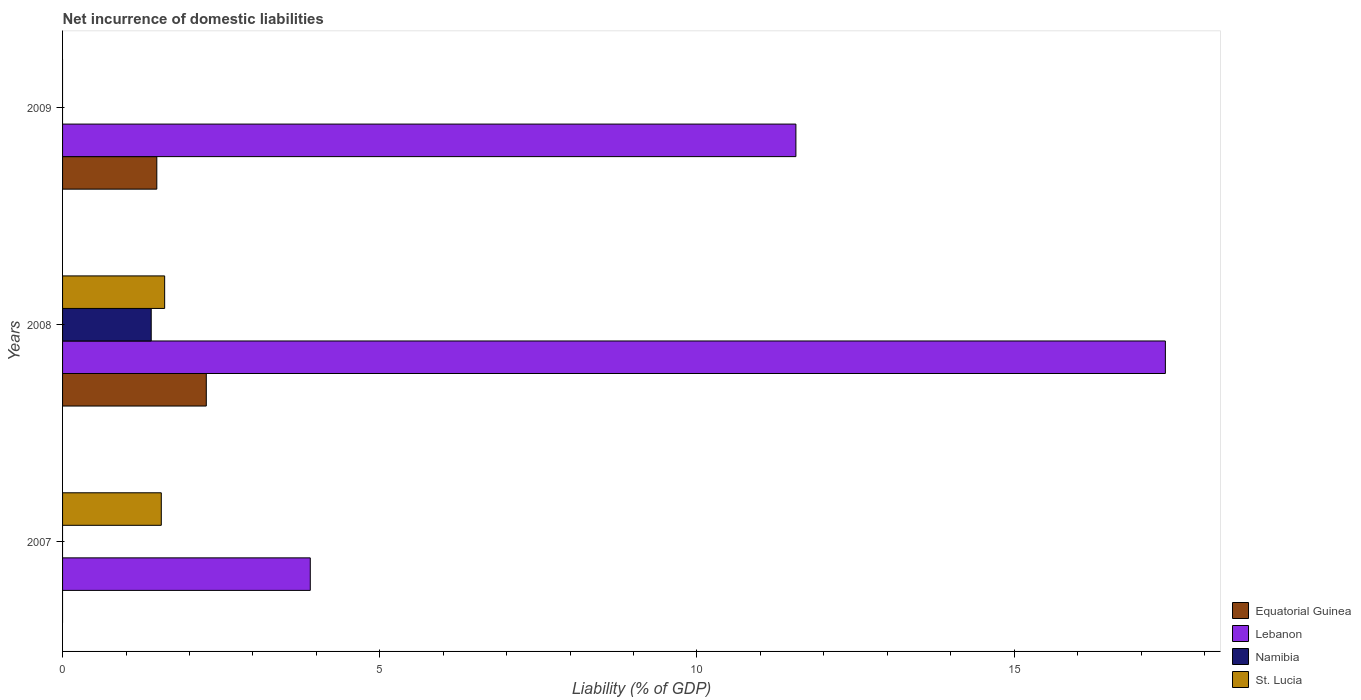How many different coloured bars are there?
Provide a short and direct response. 4. How many groups of bars are there?
Provide a succinct answer. 3. Are the number of bars per tick equal to the number of legend labels?
Your answer should be compact. No. In how many cases, is the number of bars for a given year not equal to the number of legend labels?
Offer a terse response. 2. Across all years, what is the maximum net incurrence of domestic liabilities in Namibia?
Give a very brief answer. 1.4. Across all years, what is the minimum net incurrence of domestic liabilities in St. Lucia?
Make the answer very short. 0. What is the total net incurrence of domestic liabilities in Equatorial Guinea in the graph?
Offer a very short reply. 3.75. What is the difference between the net incurrence of domestic liabilities in Lebanon in 2007 and that in 2008?
Make the answer very short. -13.48. What is the difference between the net incurrence of domestic liabilities in Namibia in 2009 and the net incurrence of domestic liabilities in St. Lucia in 2007?
Give a very brief answer. -1.56. What is the average net incurrence of domestic liabilities in Lebanon per year?
Offer a terse response. 10.95. In the year 2007, what is the difference between the net incurrence of domestic liabilities in St. Lucia and net incurrence of domestic liabilities in Lebanon?
Offer a terse response. -2.35. What is the ratio of the net incurrence of domestic liabilities in Lebanon in 2008 to that in 2009?
Ensure brevity in your answer.  1.5. What is the difference between the highest and the second highest net incurrence of domestic liabilities in Lebanon?
Your response must be concise. 5.82. What is the difference between the highest and the lowest net incurrence of domestic liabilities in Equatorial Guinea?
Provide a short and direct response. 2.27. Is the sum of the net incurrence of domestic liabilities in Equatorial Guinea in 2008 and 2009 greater than the maximum net incurrence of domestic liabilities in Namibia across all years?
Ensure brevity in your answer.  Yes. Is it the case that in every year, the sum of the net incurrence of domestic liabilities in St. Lucia and net incurrence of domestic liabilities in Equatorial Guinea is greater than the sum of net incurrence of domestic liabilities in Lebanon and net incurrence of domestic liabilities in Namibia?
Your answer should be compact. No. Is it the case that in every year, the sum of the net incurrence of domestic liabilities in Lebanon and net incurrence of domestic liabilities in Equatorial Guinea is greater than the net incurrence of domestic liabilities in Namibia?
Your answer should be compact. Yes. How many bars are there?
Give a very brief answer. 8. Are all the bars in the graph horizontal?
Ensure brevity in your answer.  Yes. How many years are there in the graph?
Your answer should be compact. 3. What is the difference between two consecutive major ticks on the X-axis?
Your answer should be very brief. 5. Are the values on the major ticks of X-axis written in scientific E-notation?
Offer a very short reply. No. Does the graph contain any zero values?
Provide a short and direct response. Yes. Does the graph contain grids?
Your answer should be very brief. No. What is the title of the graph?
Provide a short and direct response. Net incurrence of domestic liabilities. What is the label or title of the X-axis?
Provide a succinct answer. Liability (% of GDP). What is the label or title of the Y-axis?
Your answer should be compact. Years. What is the Liability (% of GDP) in Equatorial Guinea in 2007?
Your answer should be compact. 0. What is the Liability (% of GDP) in Lebanon in 2007?
Offer a terse response. 3.9. What is the Liability (% of GDP) in Namibia in 2007?
Make the answer very short. 0. What is the Liability (% of GDP) of St. Lucia in 2007?
Provide a succinct answer. 1.56. What is the Liability (% of GDP) in Equatorial Guinea in 2008?
Give a very brief answer. 2.27. What is the Liability (% of GDP) of Lebanon in 2008?
Ensure brevity in your answer.  17.38. What is the Liability (% of GDP) of Namibia in 2008?
Offer a very short reply. 1.4. What is the Liability (% of GDP) of St. Lucia in 2008?
Provide a short and direct response. 1.61. What is the Liability (% of GDP) in Equatorial Guinea in 2009?
Offer a very short reply. 1.49. What is the Liability (% of GDP) of Lebanon in 2009?
Ensure brevity in your answer.  11.56. What is the Liability (% of GDP) in Namibia in 2009?
Ensure brevity in your answer.  0. Across all years, what is the maximum Liability (% of GDP) of Equatorial Guinea?
Your answer should be compact. 2.27. Across all years, what is the maximum Liability (% of GDP) in Lebanon?
Make the answer very short. 17.38. Across all years, what is the maximum Liability (% of GDP) in Namibia?
Make the answer very short. 1.4. Across all years, what is the maximum Liability (% of GDP) of St. Lucia?
Keep it short and to the point. 1.61. Across all years, what is the minimum Liability (% of GDP) of Equatorial Guinea?
Offer a terse response. 0. Across all years, what is the minimum Liability (% of GDP) in Lebanon?
Offer a terse response. 3.9. Across all years, what is the minimum Liability (% of GDP) of St. Lucia?
Keep it short and to the point. 0. What is the total Liability (% of GDP) of Equatorial Guinea in the graph?
Keep it short and to the point. 3.75. What is the total Liability (% of GDP) in Lebanon in the graph?
Your answer should be compact. 32.85. What is the total Liability (% of GDP) of Namibia in the graph?
Your response must be concise. 1.4. What is the total Liability (% of GDP) in St. Lucia in the graph?
Provide a short and direct response. 3.17. What is the difference between the Liability (% of GDP) in Lebanon in 2007 and that in 2008?
Your answer should be compact. -13.48. What is the difference between the Liability (% of GDP) in St. Lucia in 2007 and that in 2008?
Your answer should be compact. -0.05. What is the difference between the Liability (% of GDP) in Lebanon in 2007 and that in 2009?
Your response must be concise. -7.65. What is the difference between the Liability (% of GDP) of Equatorial Guinea in 2008 and that in 2009?
Ensure brevity in your answer.  0.78. What is the difference between the Liability (% of GDP) in Lebanon in 2008 and that in 2009?
Your answer should be compact. 5.82. What is the difference between the Liability (% of GDP) in Lebanon in 2007 and the Liability (% of GDP) in Namibia in 2008?
Offer a very short reply. 2.51. What is the difference between the Liability (% of GDP) in Lebanon in 2007 and the Liability (% of GDP) in St. Lucia in 2008?
Your answer should be very brief. 2.3. What is the difference between the Liability (% of GDP) of Equatorial Guinea in 2008 and the Liability (% of GDP) of Lebanon in 2009?
Keep it short and to the point. -9.29. What is the average Liability (% of GDP) in Equatorial Guinea per year?
Your answer should be very brief. 1.25. What is the average Liability (% of GDP) of Lebanon per year?
Give a very brief answer. 10.95. What is the average Liability (% of GDP) in Namibia per year?
Ensure brevity in your answer.  0.47. What is the average Liability (% of GDP) in St. Lucia per year?
Provide a succinct answer. 1.06. In the year 2007, what is the difference between the Liability (% of GDP) in Lebanon and Liability (% of GDP) in St. Lucia?
Your answer should be very brief. 2.35. In the year 2008, what is the difference between the Liability (% of GDP) in Equatorial Guinea and Liability (% of GDP) in Lebanon?
Your response must be concise. -15.12. In the year 2008, what is the difference between the Liability (% of GDP) of Equatorial Guinea and Liability (% of GDP) of Namibia?
Ensure brevity in your answer.  0.87. In the year 2008, what is the difference between the Liability (% of GDP) of Equatorial Guinea and Liability (% of GDP) of St. Lucia?
Provide a short and direct response. 0.66. In the year 2008, what is the difference between the Liability (% of GDP) of Lebanon and Liability (% of GDP) of Namibia?
Keep it short and to the point. 15.99. In the year 2008, what is the difference between the Liability (% of GDP) in Lebanon and Liability (% of GDP) in St. Lucia?
Your answer should be compact. 15.77. In the year 2008, what is the difference between the Liability (% of GDP) in Namibia and Liability (% of GDP) in St. Lucia?
Your answer should be compact. -0.21. In the year 2009, what is the difference between the Liability (% of GDP) of Equatorial Guinea and Liability (% of GDP) of Lebanon?
Provide a short and direct response. -10.07. What is the ratio of the Liability (% of GDP) of Lebanon in 2007 to that in 2008?
Offer a very short reply. 0.22. What is the ratio of the Liability (% of GDP) of St. Lucia in 2007 to that in 2008?
Your answer should be very brief. 0.97. What is the ratio of the Liability (% of GDP) of Lebanon in 2007 to that in 2009?
Offer a very short reply. 0.34. What is the ratio of the Liability (% of GDP) in Equatorial Guinea in 2008 to that in 2009?
Ensure brevity in your answer.  1.52. What is the ratio of the Liability (% of GDP) of Lebanon in 2008 to that in 2009?
Provide a short and direct response. 1.5. What is the difference between the highest and the second highest Liability (% of GDP) in Lebanon?
Give a very brief answer. 5.82. What is the difference between the highest and the lowest Liability (% of GDP) of Equatorial Guinea?
Offer a terse response. 2.27. What is the difference between the highest and the lowest Liability (% of GDP) of Lebanon?
Ensure brevity in your answer.  13.48. What is the difference between the highest and the lowest Liability (% of GDP) in Namibia?
Your response must be concise. 1.4. What is the difference between the highest and the lowest Liability (% of GDP) of St. Lucia?
Your response must be concise. 1.61. 